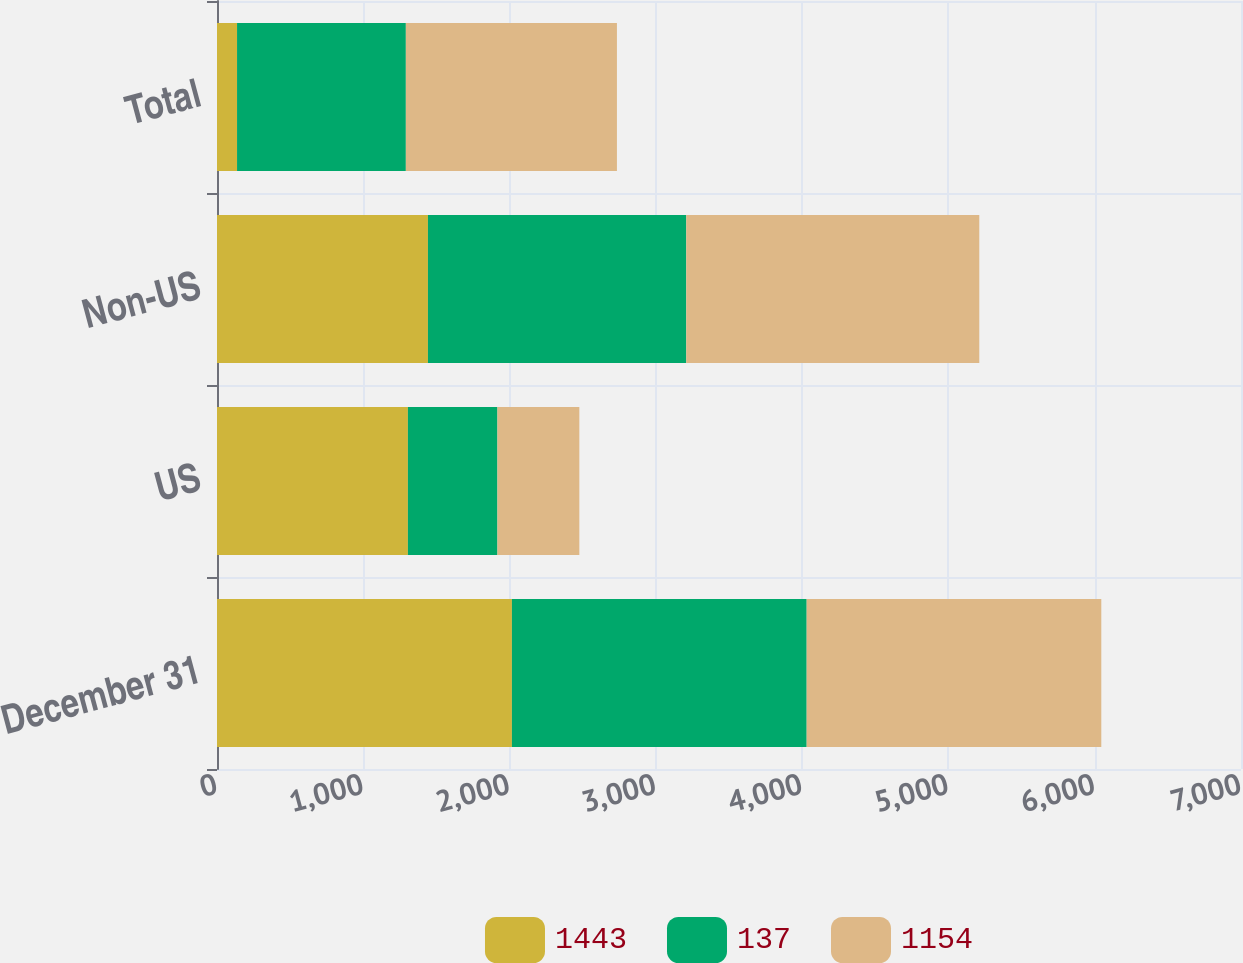Convert chart to OTSL. <chart><loc_0><loc_0><loc_500><loc_500><stacked_bar_chart><ecel><fcel>December 31<fcel>US<fcel>Non-US<fcel>Total<nl><fcel>1443<fcel>2016<fcel>1305<fcel>1442<fcel>137<nl><fcel>137<fcel>2015<fcel>612<fcel>1766<fcel>1154<nl><fcel>1154<fcel>2014<fcel>560<fcel>2003<fcel>1443<nl></chart> 